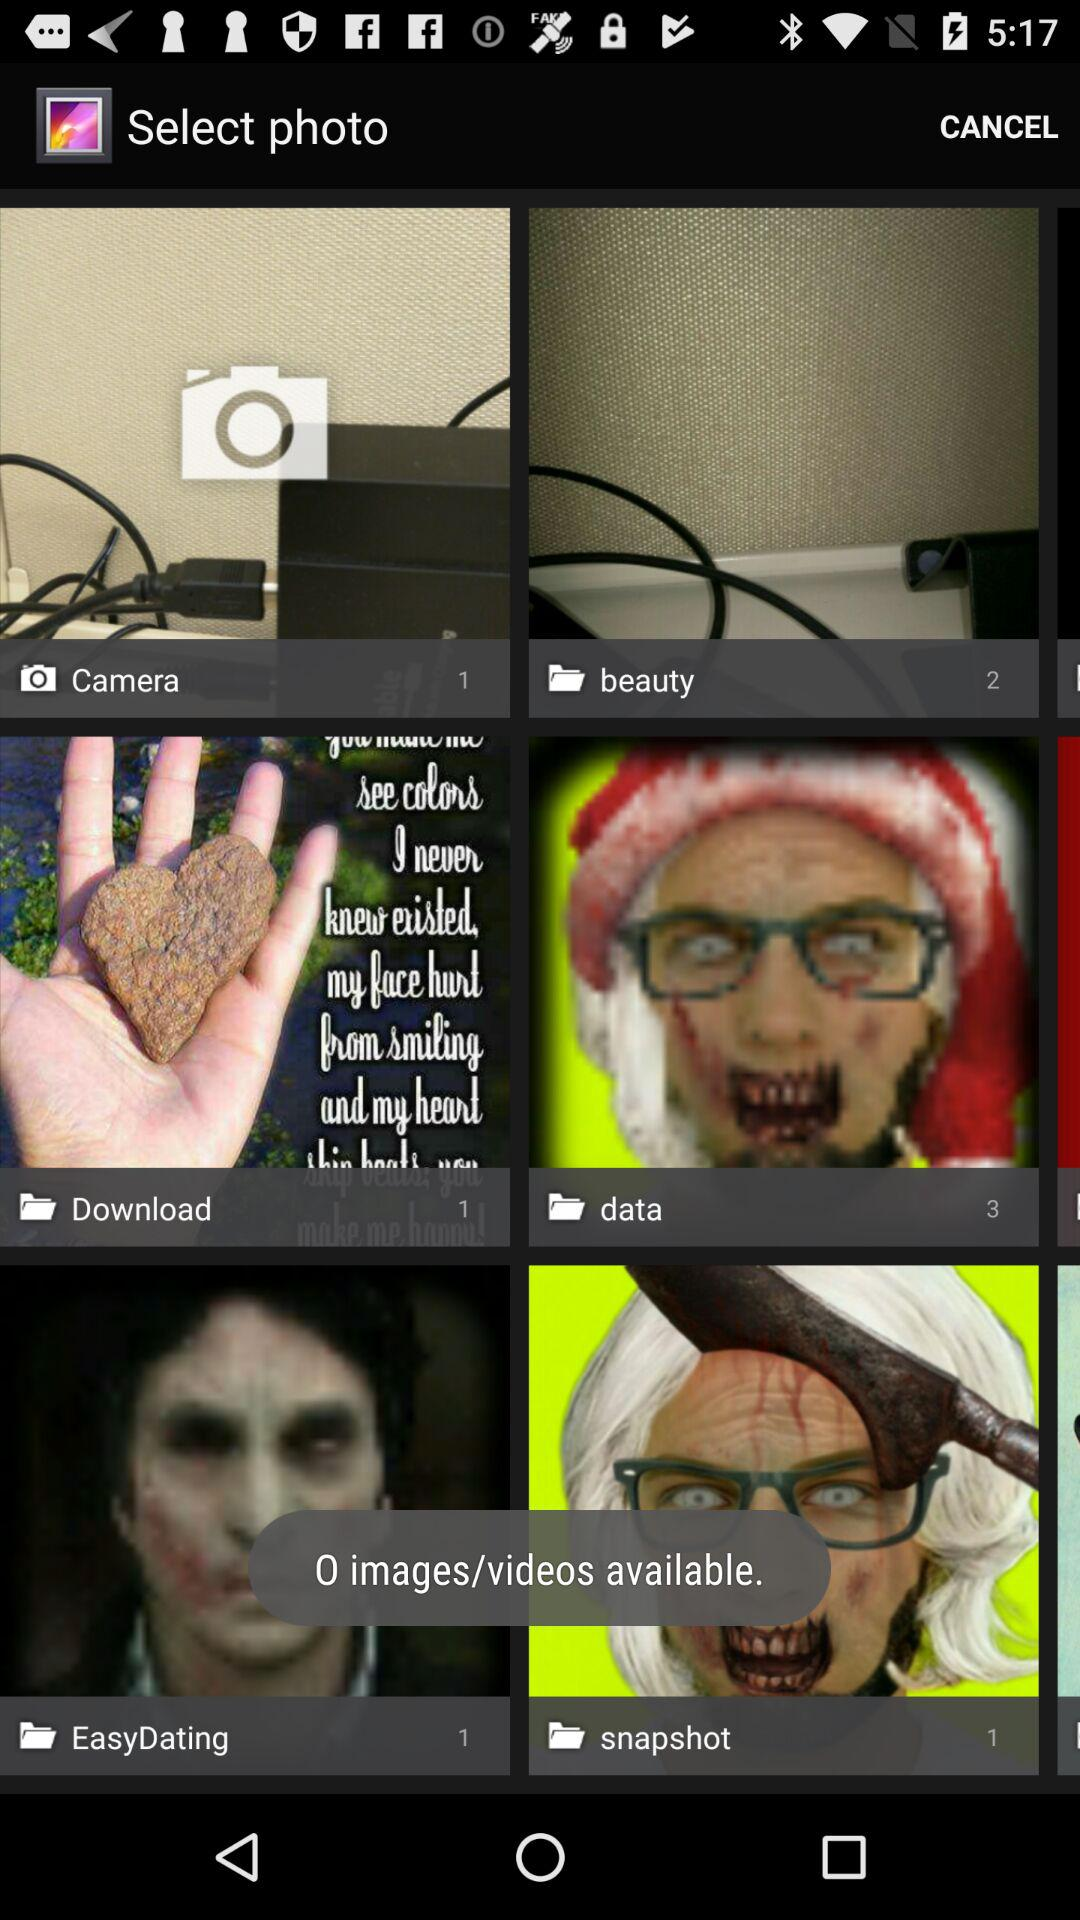How many photos are shown in "Camera"? There is 1 photo shown in "Camera". 